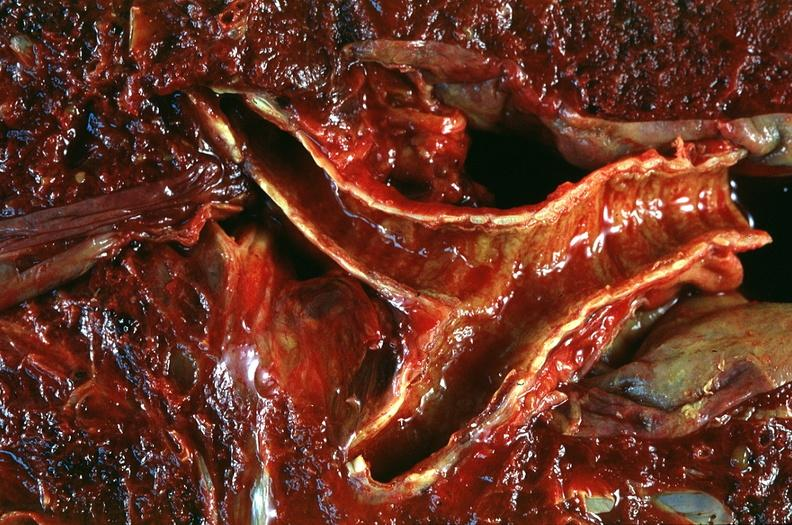what is present?
Answer the question using a single word or phrase. Respiratory 